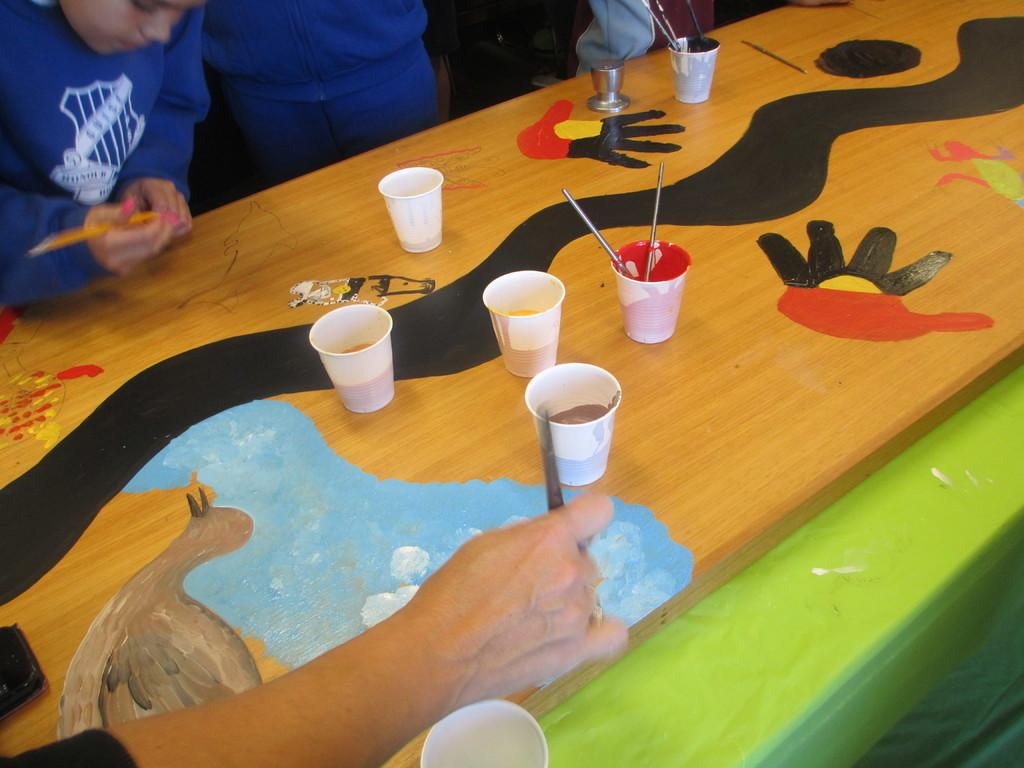What is the main object in the image? There is a table in the image. What is on the table? There are glasses with paint on the table, as well as paint brushes. Is there anyone else in the image besides the person in the background? No, the person in the background is the only other person visible in the image. What is the person in the background doing? The person is catching a paint brush. What type of honey is being used to reward the person in the image? There is no honey present in the image, and no rewards are being given. 